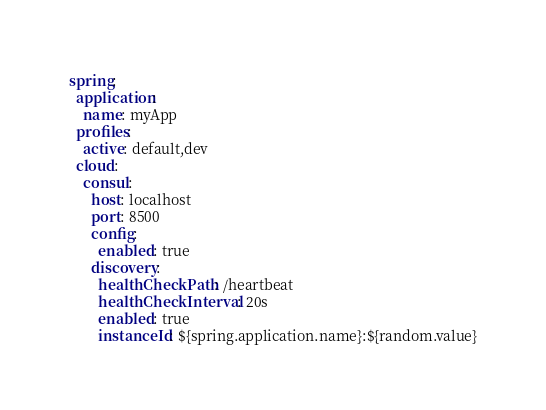Convert code to text. <code><loc_0><loc_0><loc_500><loc_500><_YAML_>spring:
  application:
    name: myApp
  profiles:
    active: default,dev
  cloud:
    consul:
      host: localhost
      port: 8500
      config:
        enabled: true
      discovery:
        healthCheckPath: /heartbeat
        healthCheckInterval: 20s
        enabled: true
        instanceId: ${spring.application.name}:${random.value}
</code> 